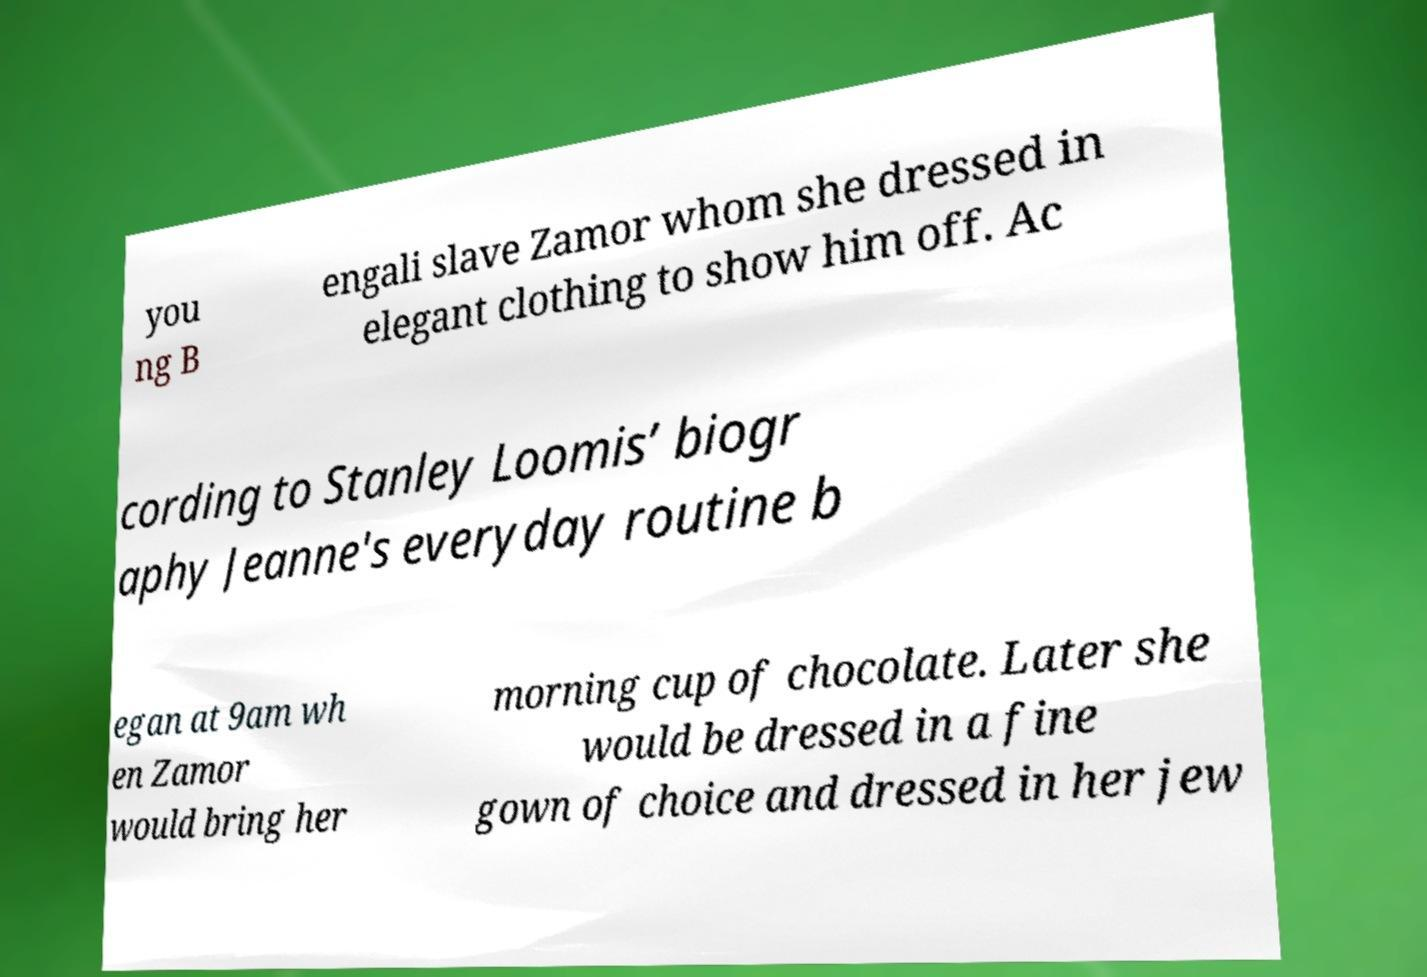Please identify and transcribe the text found in this image. you ng B engali slave Zamor whom she dressed in elegant clothing to show him off. Ac cording to Stanley Loomis’ biogr aphy Jeanne's everyday routine b egan at 9am wh en Zamor would bring her morning cup of chocolate. Later she would be dressed in a fine gown of choice and dressed in her jew 